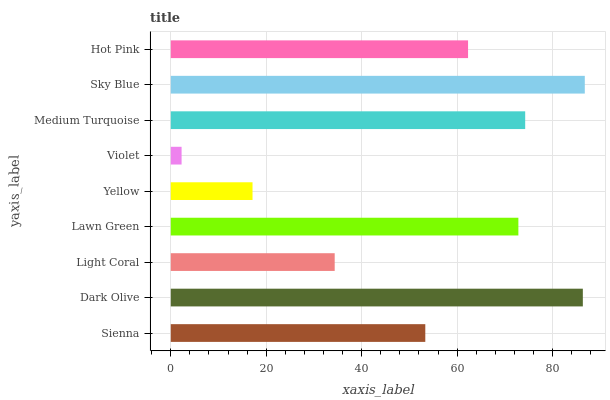Is Violet the minimum?
Answer yes or no. Yes. Is Sky Blue the maximum?
Answer yes or no. Yes. Is Dark Olive the minimum?
Answer yes or no. No. Is Dark Olive the maximum?
Answer yes or no. No. Is Dark Olive greater than Sienna?
Answer yes or no. Yes. Is Sienna less than Dark Olive?
Answer yes or no. Yes. Is Sienna greater than Dark Olive?
Answer yes or no. No. Is Dark Olive less than Sienna?
Answer yes or no. No. Is Hot Pink the high median?
Answer yes or no. Yes. Is Hot Pink the low median?
Answer yes or no. Yes. Is Lawn Green the high median?
Answer yes or no. No. Is Yellow the low median?
Answer yes or no. No. 